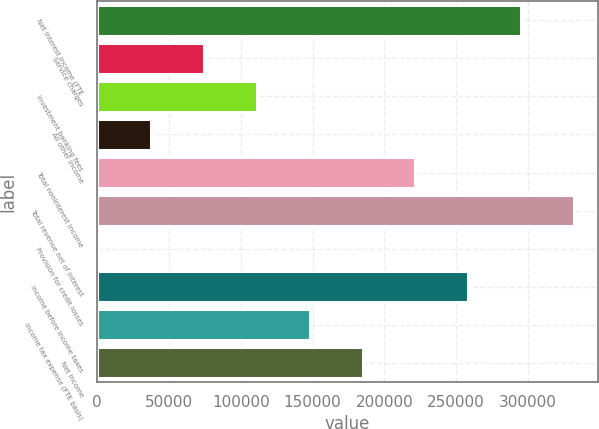Convert chart to OTSL. <chart><loc_0><loc_0><loc_500><loc_500><bar_chart><fcel>Net interest income (FTE<fcel>Service charges<fcel>Investment banking fees<fcel>All other income<fcel>Total noninterest income<fcel>Total revenue net of interest<fcel>Provision for credit losses<fcel>Income before income taxes<fcel>Income tax expense (FTE basis)<fcel>Net income<nl><fcel>295338<fcel>74349<fcel>111180<fcel>37517.5<fcel>221675<fcel>332170<fcel>686<fcel>258506<fcel>148012<fcel>184844<nl></chart> 